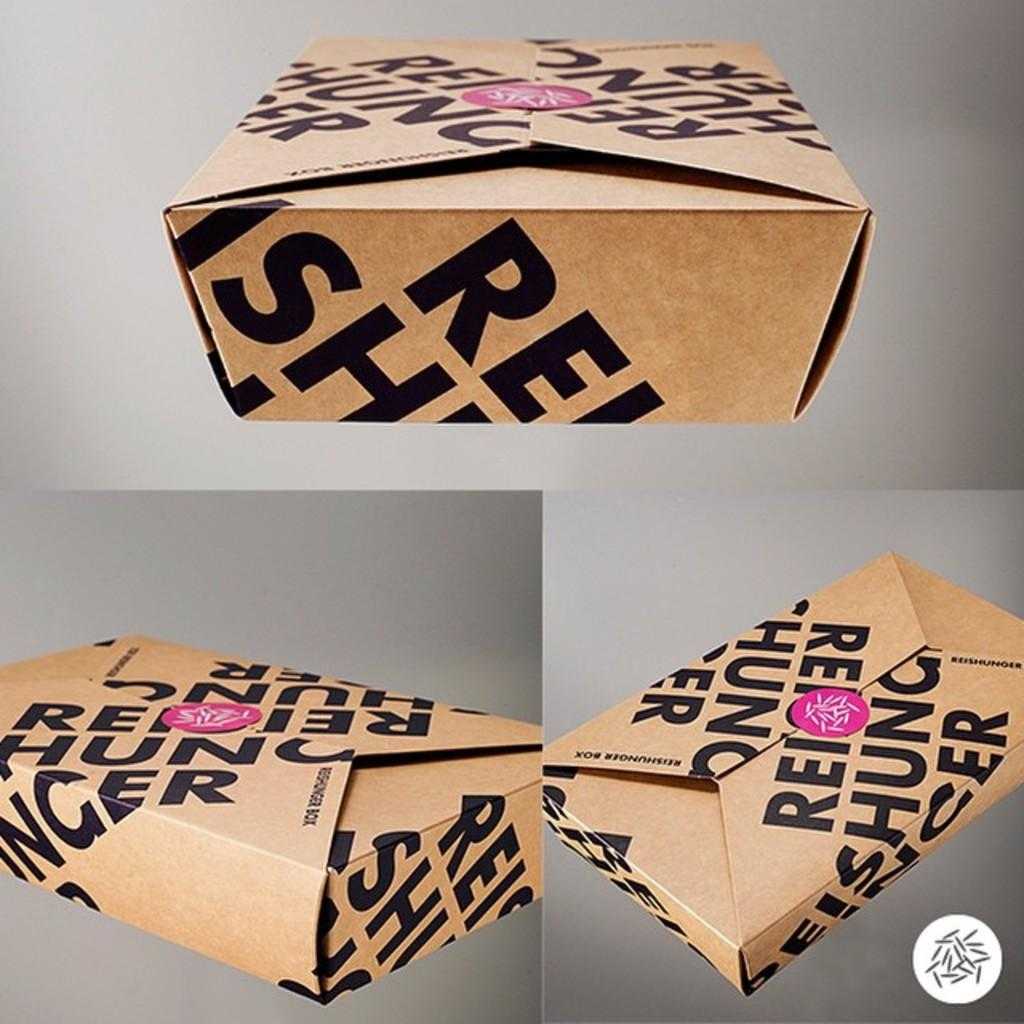<image>
Present a compact description of the photo's key features. Three images of a brown box from Rei Shunger. 